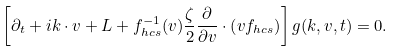<formula> <loc_0><loc_0><loc_500><loc_500>\left [ \partial _ { t } + i k \cdot v + L + f _ { h c s } ^ { - 1 } ( v ) \frac { \zeta } { 2 } \frac { \partial } { \partial v } \cdot \left ( v f _ { h c s } \right ) \right ] g ( k , v , t ) = 0 .</formula> 